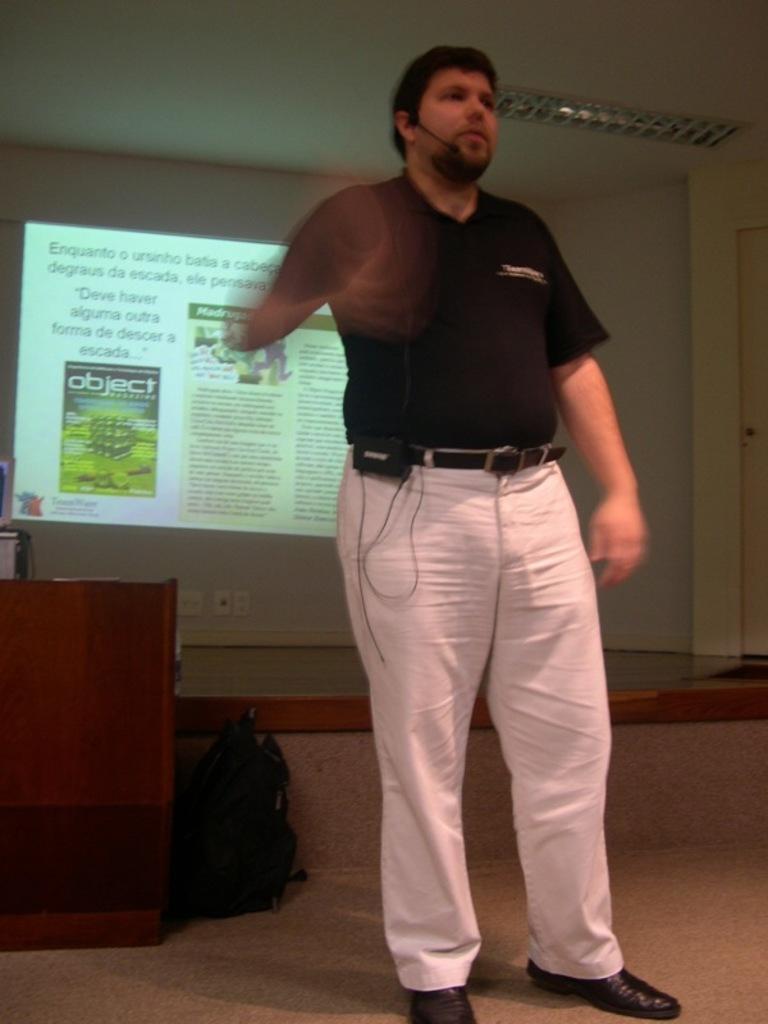Please provide a concise description of this image. In the image there is a man standing and giving a presentation, behind him there is a screen and it is showing some information. The hand of the man is blur, he is wearing a mike around his head and in the background there is a wall, on the left side there is a table and beside the table there is a bag. 